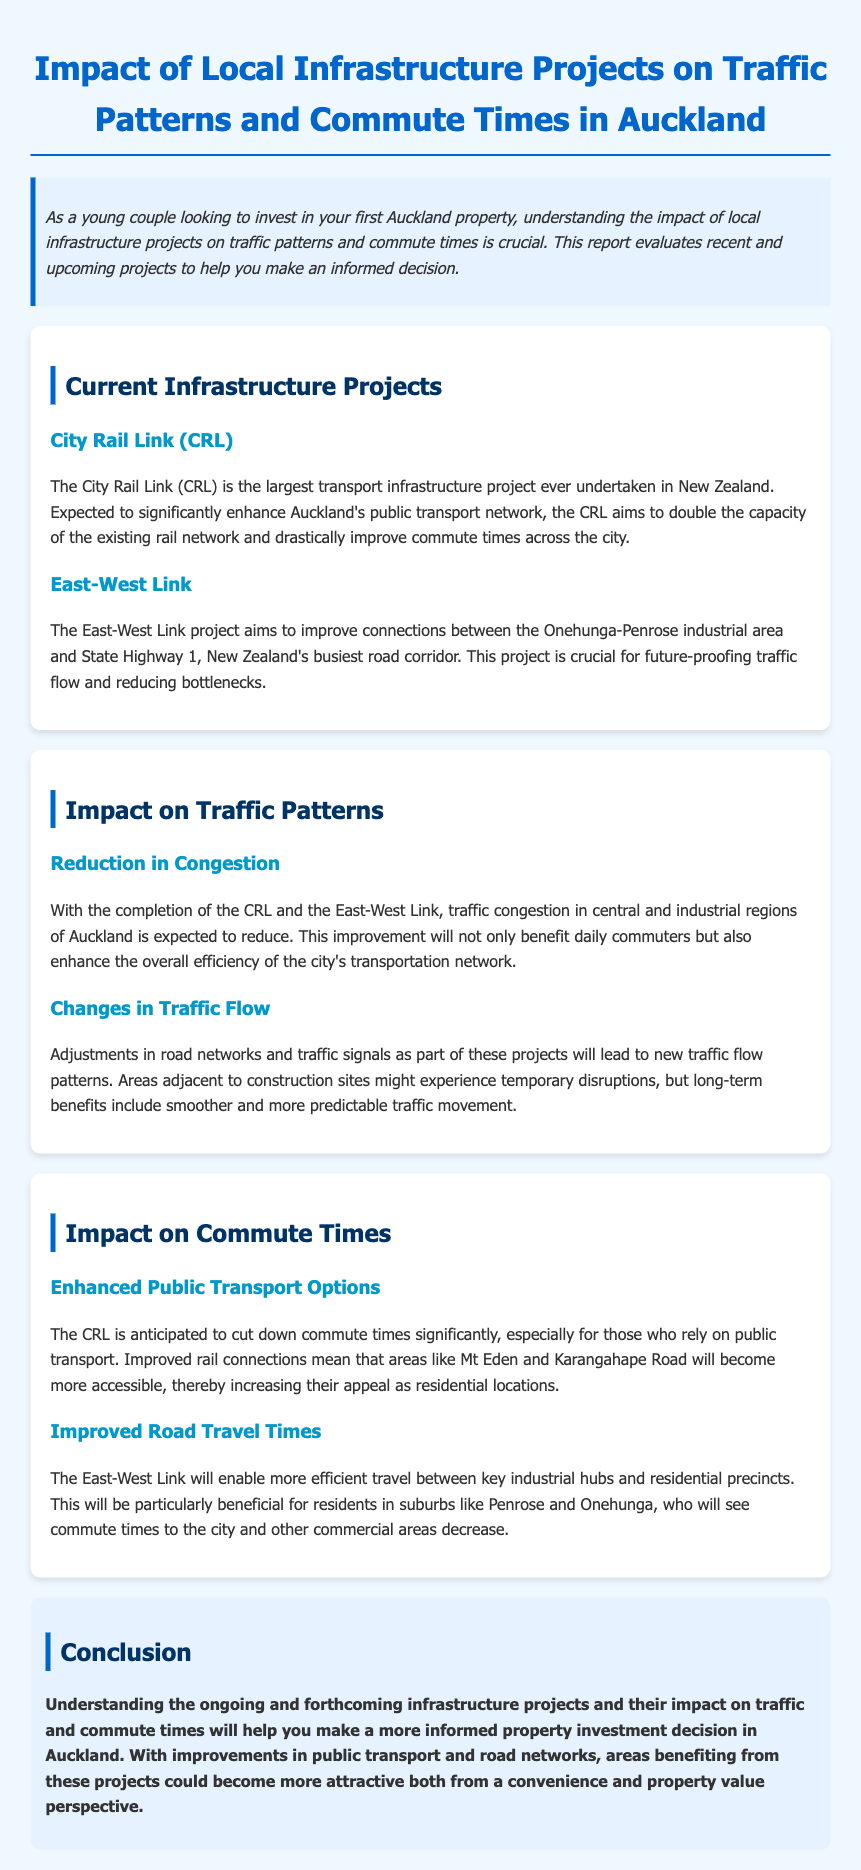What is the largest transport infrastructure project in New Zealand? The City Rail Link (CRL) is the largest transport infrastructure project ever undertaken in New Zealand.
Answer: City Rail Link (CRL) What two areas does the East-West Link connect? The East-West Link project aims to improve connections between the Onehunga-Penrose industrial area and State Highway 1.
Answer: Onehunga-Penrose and State Highway 1 What is expected to happen to traffic congestion in Auckland? The report states that traffic congestion in central and industrial regions of Auckland is expected to reduce.
Answer: Reduce How will the City Rail Link affect commute times? The report mentions that the CRL is anticipated to cut down commute times significantly for those who rely on public transport.
Answer: Cut down What will the East-West Link enable for residents in suburbs like Penrose and Onehunga? The East-West Link will enable more efficient travel between key industrial hubs and residential precincts, benefiting residents.
Answer: Efficient travel What type of report is this document? The document evaluates recent and upcoming projects related to transportation in Auckland.
Answer: Traffic report What type of improvements does the City Rail Link aim for? The City Rail Link aims to double the capacity of the existing rail network.
Answer: Double the capacity What are two key outcomes mentioned in relation to traffic flow changes? The report states new traffic flow patterns and smoother traffic movement as key outcomes.
Answer: New traffic flow patterns and smoother traffic movement 